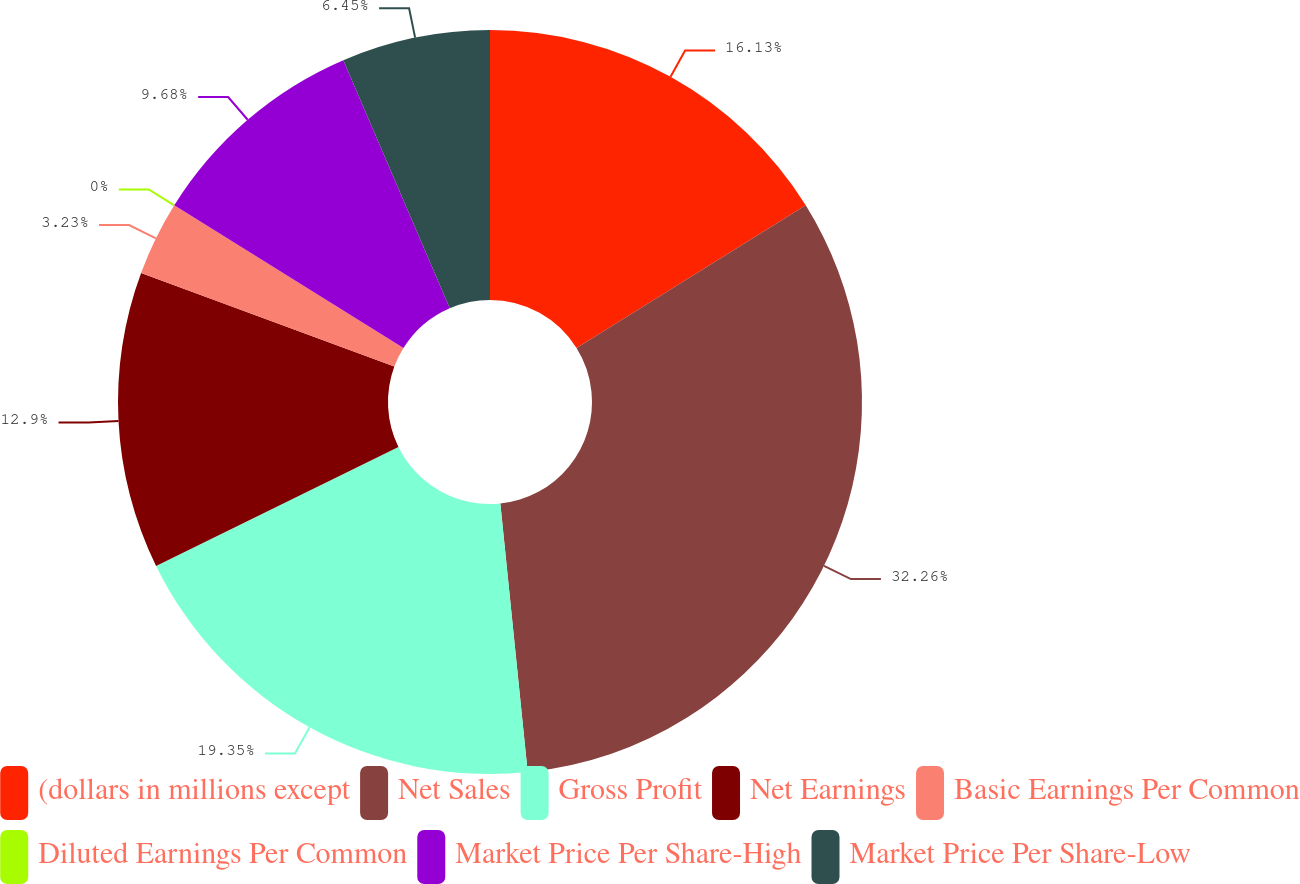Convert chart. <chart><loc_0><loc_0><loc_500><loc_500><pie_chart><fcel>(dollars in millions except<fcel>Net Sales<fcel>Gross Profit<fcel>Net Earnings<fcel>Basic Earnings Per Common<fcel>Diluted Earnings Per Common<fcel>Market Price Per Share-High<fcel>Market Price Per Share-Low<nl><fcel>16.13%<fcel>32.25%<fcel>19.35%<fcel>12.9%<fcel>3.23%<fcel>0.0%<fcel>9.68%<fcel>6.45%<nl></chart> 